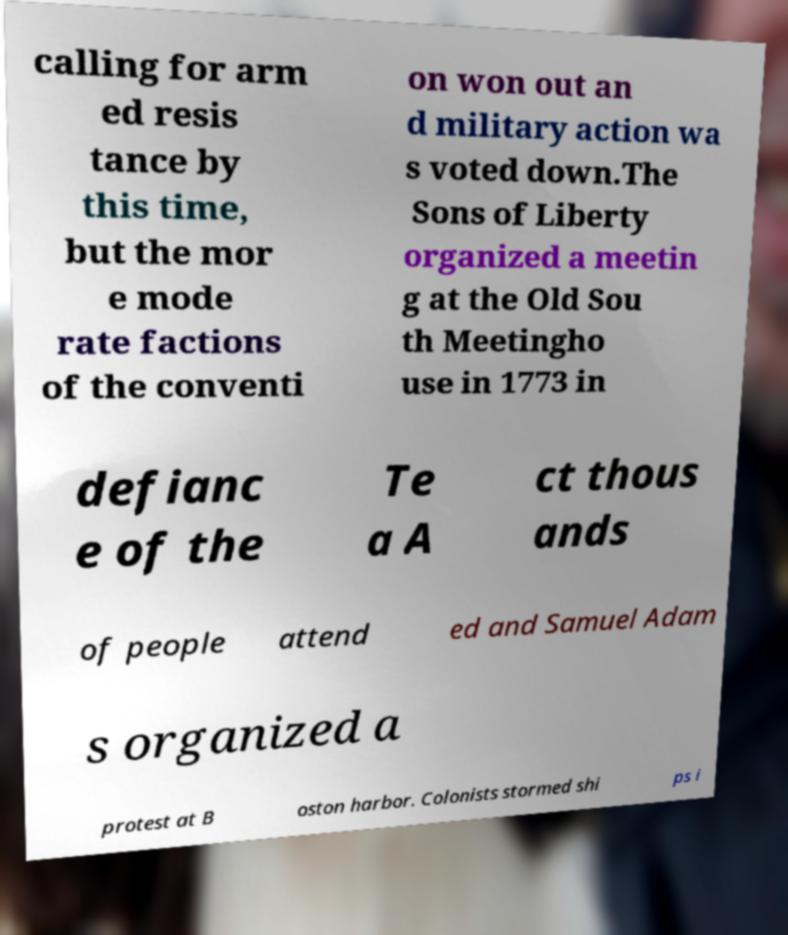Please read and relay the text visible in this image. What does it say? calling for arm ed resis tance by this time, but the mor e mode rate factions of the conventi on won out an d military action wa s voted down.The Sons of Liberty organized a meetin g at the Old Sou th Meetingho use in 1773 in defianc e of the Te a A ct thous ands of people attend ed and Samuel Adam s organized a protest at B oston harbor. Colonists stormed shi ps i 